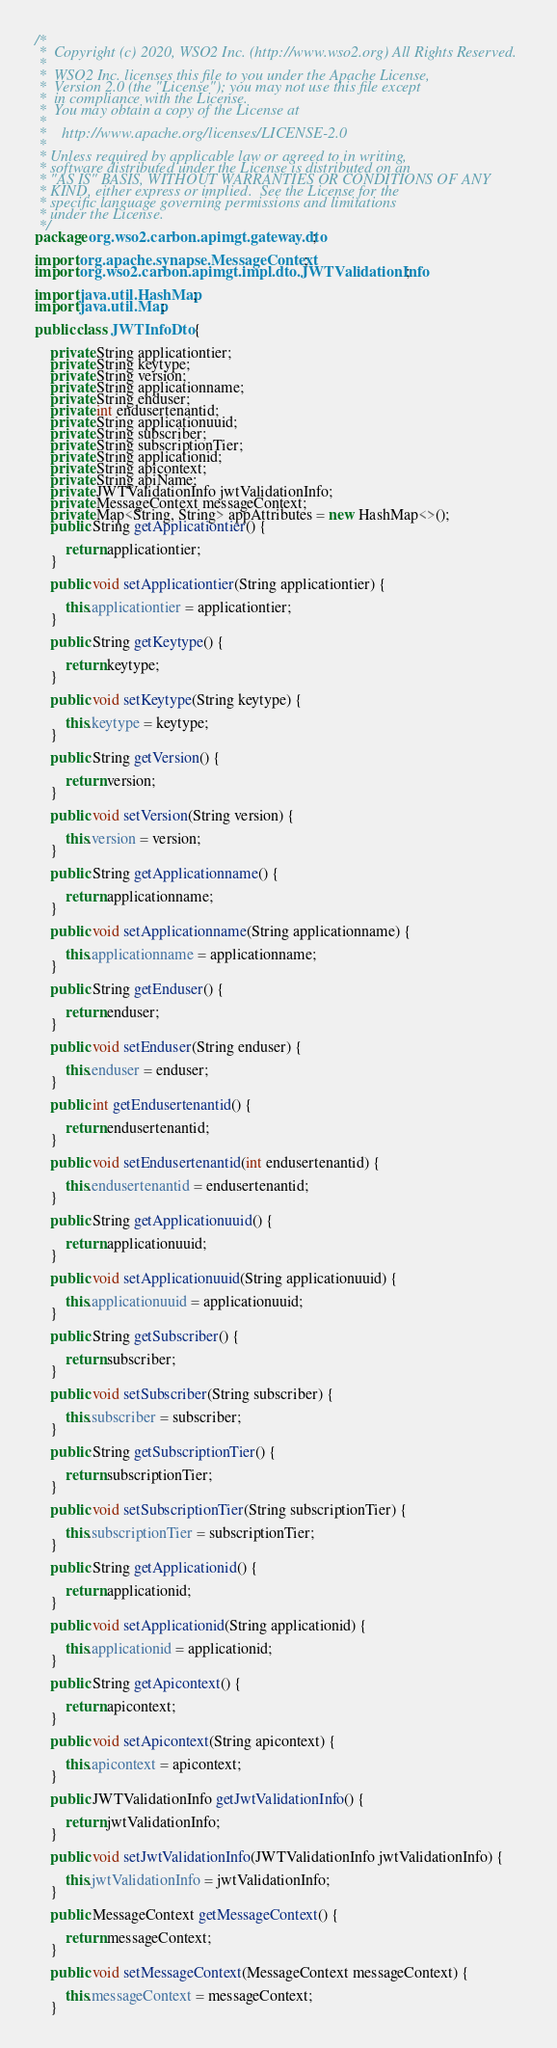Convert code to text. <code><loc_0><loc_0><loc_500><loc_500><_Java_>/*
 *  Copyright (c) 2020, WSO2 Inc. (http://www.wso2.org) All Rights Reserved.
 *
 *  WSO2 Inc. licenses this file to you under the Apache License,
 *  Version 2.0 (the "License"); you may not use this file except
 *  in compliance with the License.
 *  You may obtain a copy of the License at
 *
 *    http://www.apache.org/licenses/LICENSE-2.0
 *
 * Unless required by applicable law or agreed to in writing,
 * software distributed under the License is distributed on an
 * "AS IS" BASIS, WITHOUT WARRANTIES OR CONDITIONS OF ANY
 * KIND, either express or implied.  See the License for the
 * specific language governing permissions and limitations
 * under the License.
 */
package org.wso2.carbon.apimgt.gateway.dto;

import org.apache.synapse.MessageContext;
import org.wso2.carbon.apimgt.impl.dto.JWTValidationInfo;

import java.util.HashMap;
import java.util.Map;

public class JWTInfoDto {

    private String applicationtier;
    private String keytype;
    private String version;
    private String applicationname;
    private String enduser;
    private int endusertenantid;
    private String applicationuuid;
    private String subscriber;
    private String subscriptionTier;
    private String applicationid;
    private String apicontext;
    private String apiName;
    private JWTValidationInfo jwtValidationInfo;
    private MessageContext messageContext;
    private Map<String, String> appAttributes = new HashMap<>();
    public String getApplicationtier() {

        return applicationtier;
    }

    public void setApplicationtier(String applicationtier) {

        this.applicationtier = applicationtier;
    }

    public String getKeytype() {

        return keytype;
    }

    public void setKeytype(String keytype) {

        this.keytype = keytype;
    }

    public String getVersion() {

        return version;
    }

    public void setVersion(String version) {

        this.version = version;
    }

    public String getApplicationname() {

        return applicationname;
    }

    public void setApplicationname(String applicationname) {

        this.applicationname = applicationname;
    }

    public String getEnduser() {

        return enduser;
    }

    public void setEnduser(String enduser) {

        this.enduser = enduser;
    }

    public int getEndusertenantid() {

        return endusertenantid;
    }

    public void setEndusertenantid(int endusertenantid) {

        this.endusertenantid = endusertenantid;
    }

    public String getApplicationuuid() {

        return applicationuuid;
    }

    public void setApplicationuuid(String applicationuuid) {

        this.applicationuuid = applicationuuid;
    }

    public String getSubscriber() {

        return subscriber;
    }

    public void setSubscriber(String subscriber) {

        this.subscriber = subscriber;
    }

    public String getSubscriptionTier() {

        return subscriptionTier;
    }

    public void setSubscriptionTier(String subscriptionTier) {

        this.subscriptionTier = subscriptionTier;
    }

    public String getApplicationid() {

        return applicationid;
    }

    public void setApplicationid(String applicationid) {

        this.applicationid = applicationid;
    }

    public String getApicontext() {

        return apicontext;
    }

    public void setApicontext(String apicontext) {

        this.apicontext = apicontext;
    }

    public JWTValidationInfo getJwtValidationInfo() {

        return jwtValidationInfo;
    }

    public void setJwtValidationInfo(JWTValidationInfo jwtValidationInfo) {

        this.jwtValidationInfo = jwtValidationInfo;
    }

    public MessageContext getMessageContext() {

        return messageContext;
    }

    public void setMessageContext(MessageContext messageContext) {

        this.messageContext = messageContext;
    }
</code> 